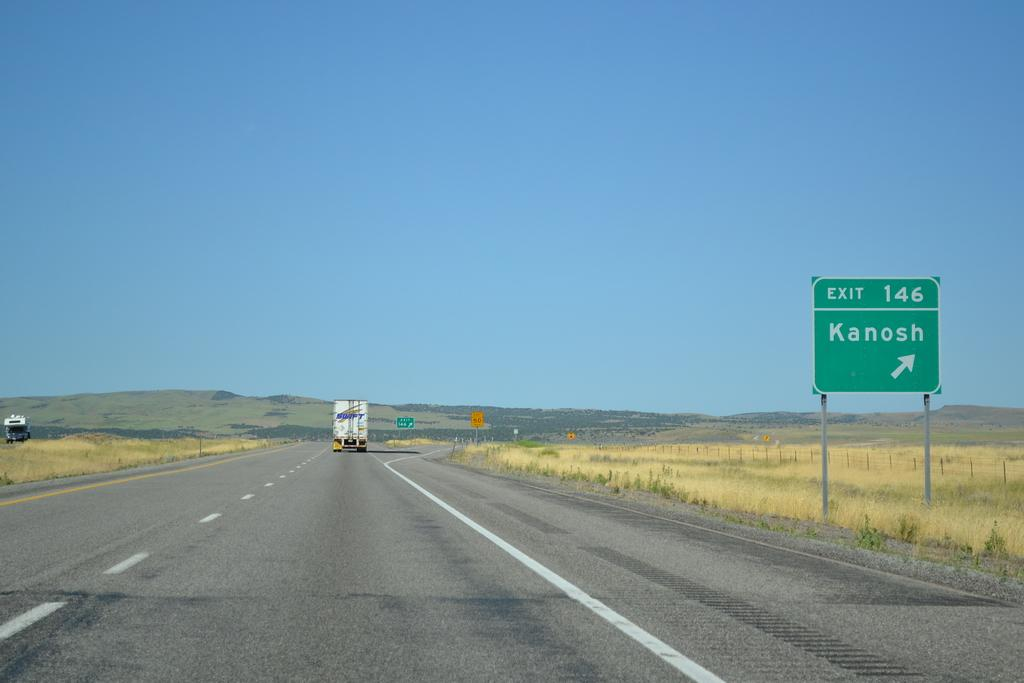<image>
Give a short and clear explanation of the subsequent image. an empty highway with a sign for Kanosh Exit 146 